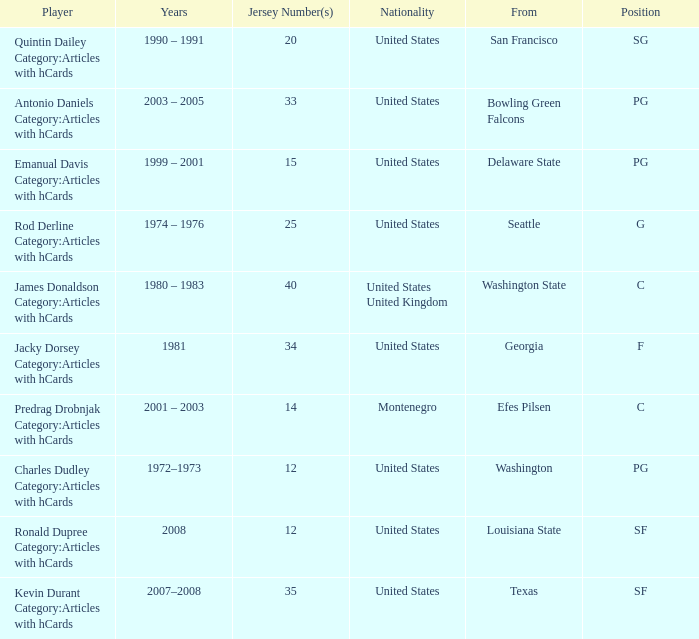What years did the united states player with a jersey number 25 who attended delaware state play? 1999 – 2001. 